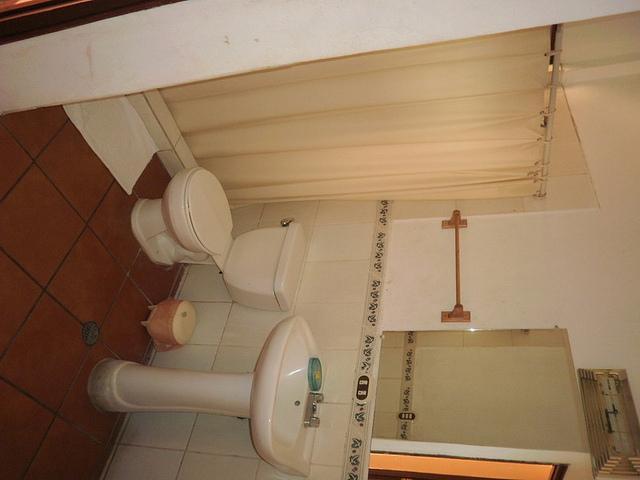How many people are on the lift?
Give a very brief answer. 0. 